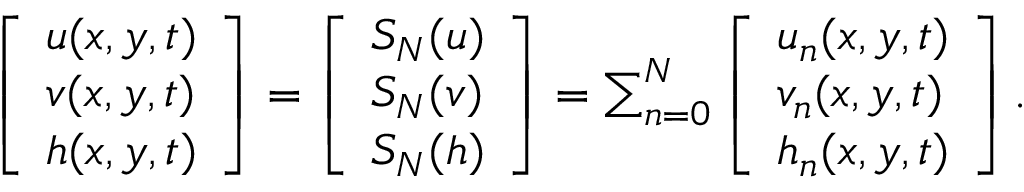Convert formula to latex. <formula><loc_0><loc_0><loc_500><loc_500>\begin{array} { r } { \left [ \begin{array} { l } { u ( x , y , t ) } \\ { v ( x , y , t ) } \\ { h ( x , y , t ) } \end{array} \right ] = \left [ \begin{array} { l } { S _ { N } ( u ) } \\ { S _ { N } ( v ) } \\ { S _ { N } ( h ) } \end{array} \right ] = \sum _ { n = 0 } ^ { N } \left [ \begin{array} { l } { u _ { n } ( x , y , t ) } \\ { v _ { n } ( x , y , t ) } \\ { h _ { n } ( x , y , t ) } \end{array} \right ] . } \end{array}</formula> 